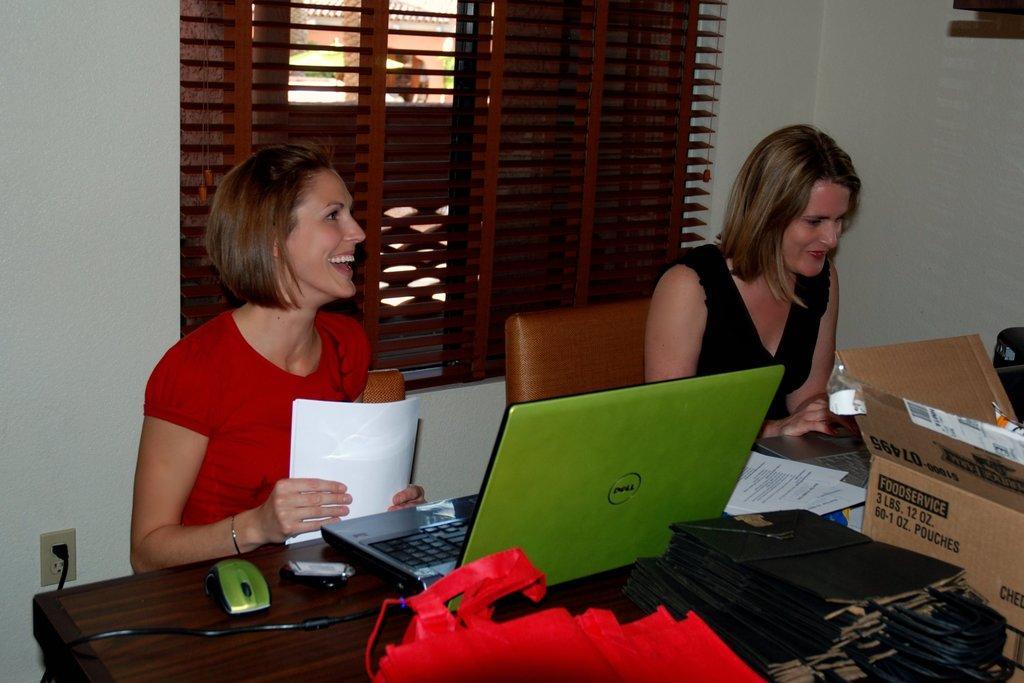Could you give a brief overview of what you see in this image? These two persons are sitting on the chair and smiling and this person holding papers. We can see laptops,papers,covers,bags,cable,mouse,cardboard box on the table. Behind these two persons we can see wall,window. 